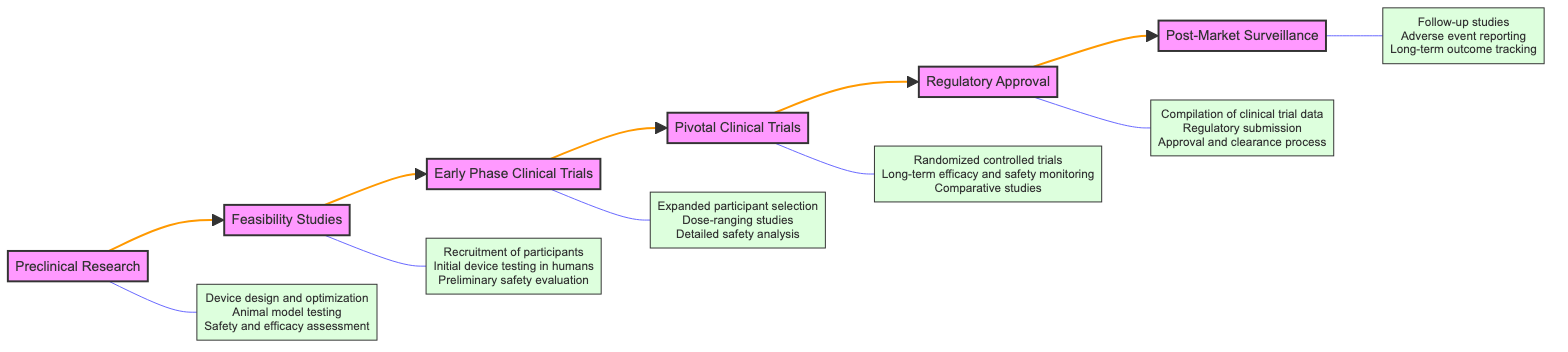What is the first stage in the development of a brain-computer interface? According to the flowchart, the first stage is labeled "Preclinical Research," which is the starting point for developing brain-computer interface prototypes.
Answer: Preclinical Research How many total stages are there in the process? By counting the stages listed in the flowchart, there are six distinct stages from Preclinical Research to Post-Market Surveillance.
Answer: Six What key activity is associated with Pivotal Clinical Trials? The key activities listed for Pivotal Clinical Trials include "Randomized controlled trials," which is an essential aspect of this stage for confirming efficacy.
Answer: Randomized controlled trials Which stage follows Early Phase Clinical Trials? The flowchart shows that after Early Phase Clinical Trials, the next stage is "Pivotal Clinical Trials," indicating the progression of the development process.
Answer: Pivotal Clinical Trials What types of entities are involved in the Regulatory Approval stage? The flowchart specifically mentions involved entities such as the FDA and EMA, which are regulatory bodies for approval of medical devices like brain-computer interfaces.
Answer: FDA, EMA What is the primary focus during Post-Market Surveillance? The flowchart mentions "Continuous monitoring of the brain-computer interface's performance and safety" as the focus during Post-Market Surveillance, highlighting its ongoing importance after approval.
Answer: Continuous monitoring What activities are conducted during the Feasibility Studies? The flowchart outlines the key activities for Feasibility Studies, which include "Recruitment of participants" and "Initial device testing in humans," relevant for determining basic safety and functionality.
Answer: Recruitment of participants, Initial device testing in humans Which stage includes expanded participant selection as a key activity? The key activity of expanded participant selection is stated under "Early Phase Clinical Trials," where trials are conducted with a larger cohort of patients for better evaluation.
Answer: Early Phase Clinical Trials How are the stages connected? The stages are connected in a sequential flow from Preclinical Research to Post-Market Surveillance, indicating the chronological order of development and evaluation in clinical trials.
Answer: Sequential flow 